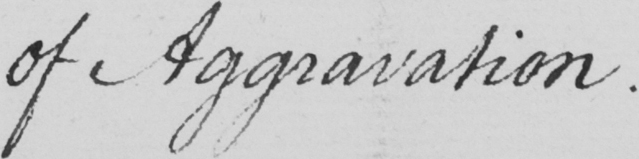What text is written in this handwritten line? of Aggravation . 